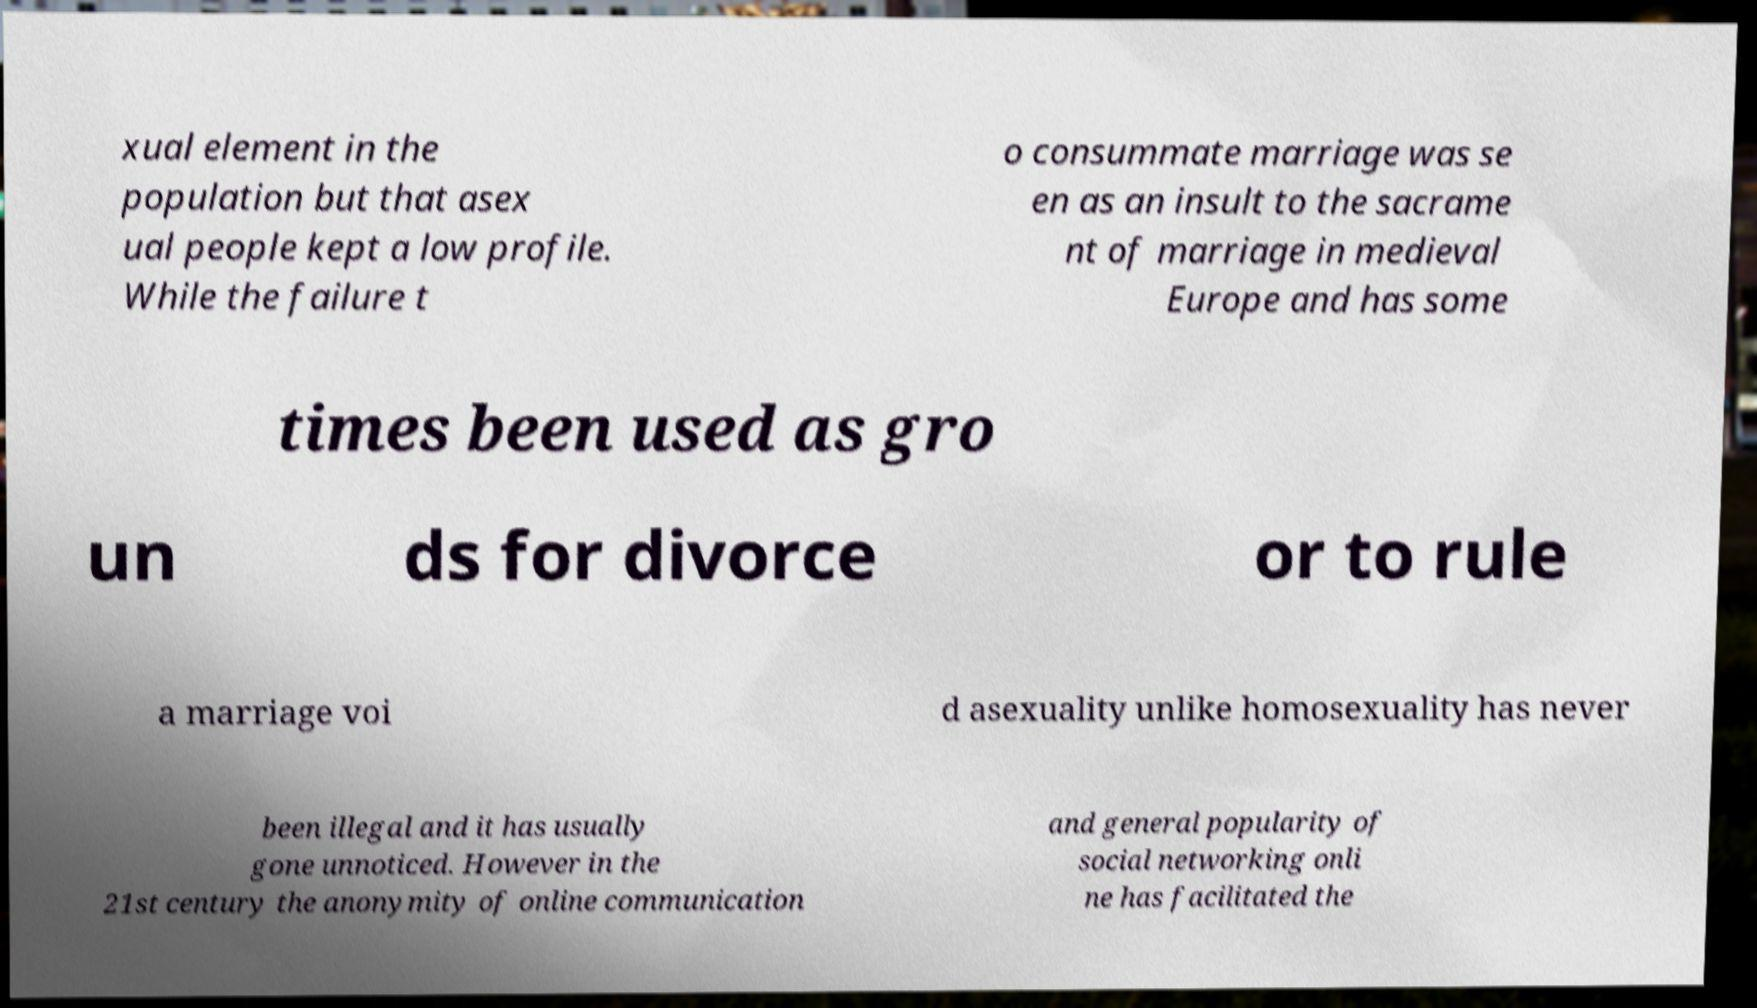For documentation purposes, I need the text within this image transcribed. Could you provide that? xual element in the population but that asex ual people kept a low profile. While the failure t o consummate marriage was se en as an insult to the sacrame nt of marriage in medieval Europe and has some times been used as gro un ds for divorce or to rule a marriage voi d asexuality unlike homosexuality has never been illegal and it has usually gone unnoticed. However in the 21st century the anonymity of online communication and general popularity of social networking onli ne has facilitated the 